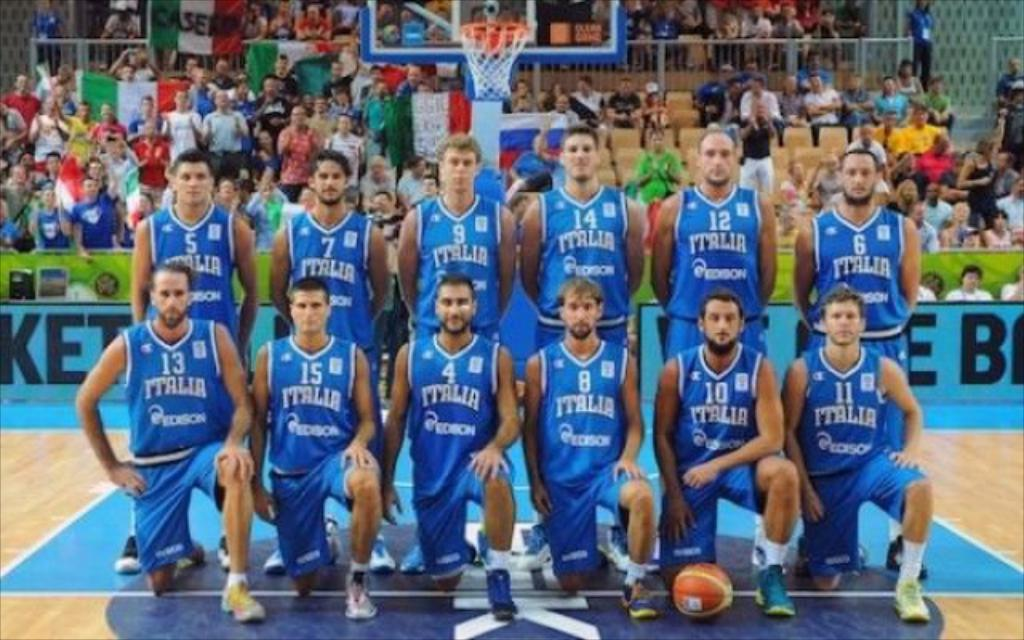<image>
Write a terse but informative summary of the picture. A men's basketball team poses for a picture after a game. 